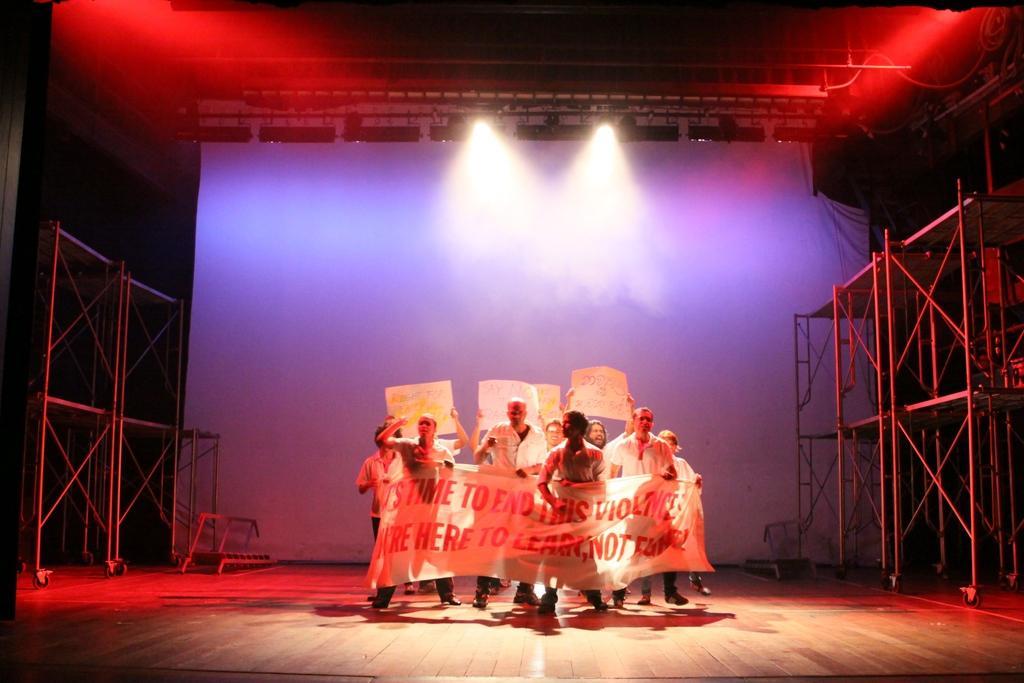Please provide a concise description of this image. In this picture I can see group of people standing on the stage and holding the papers and a banner, there are focus lights, iron rods and some other items. 